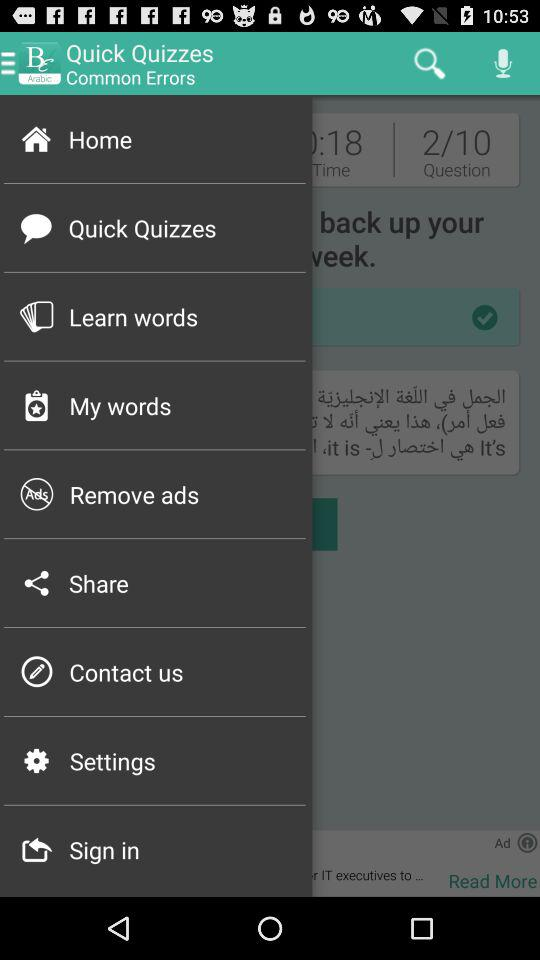Which question am I answering? You are answering question 2. 